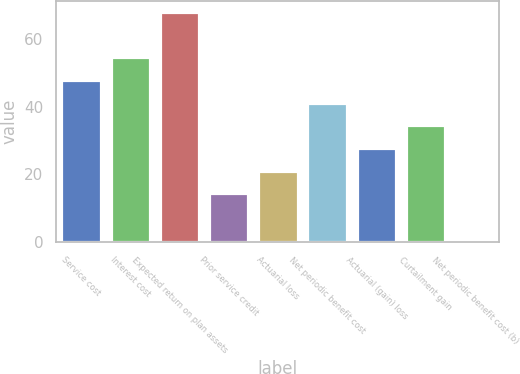<chart> <loc_0><loc_0><loc_500><loc_500><bar_chart><fcel>Service cost<fcel>Interest cost<fcel>Expected return on plan assets<fcel>Prior service credit<fcel>Actuarial loss<fcel>Net periodic benefit cost<fcel>Actuarial (gain) loss<fcel>Curtailment gain<fcel>Net periodic benefit cost (b)<nl><fcel>47.9<fcel>54.6<fcel>68<fcel>14.4<fcel>21.1<fcel>41.2<fcel>27.8<fcel>34.5<fcel>1<nl></chart> 